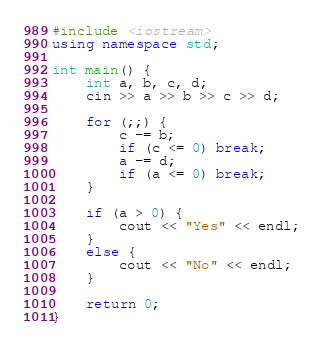<code> <loc_0><loc_0><loc_500><loc_500><_C++_>#include <iostream>
using namespace std;

int main() {
	int a, b, c, d;
	cin >> a >> b >> c >> d;

	for (;;) {
		c -= b;
		if (c <= 0) break;
		a -= d;
		if (a <= 0) break;
	}

	if (a > 0) {
		cout << "Yes" << endl;
	}
	else {
		cout << "No" << endl;
	}

	return 0;
}</code> 